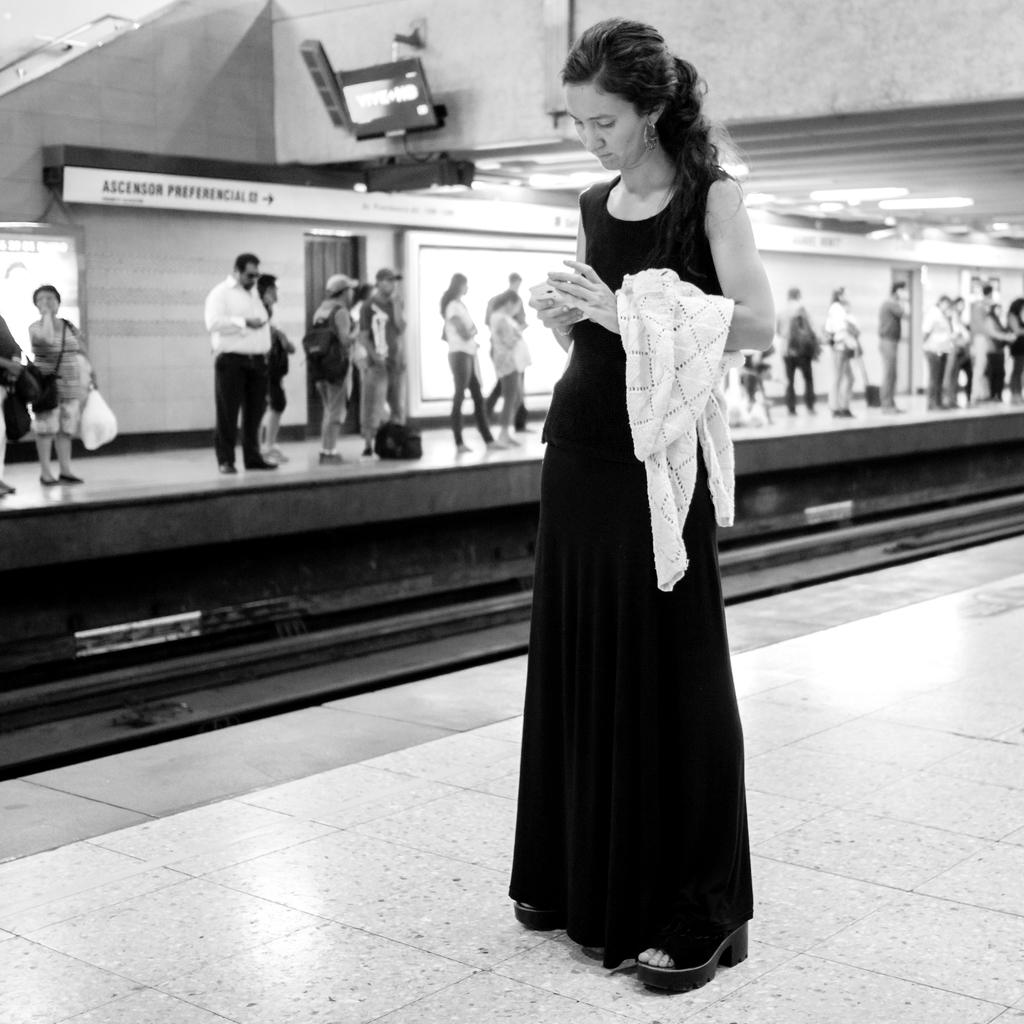What can be seen in the image involving transportation? There is a railway track and a platform in the image. What are the people in the image doing? The people are standing in the image. What is above the people in the image? The ceiling with lights is visible in the image. What is written or displayed on a surface in the image? There is text written on a wall in the image. What type of eggnog is being served to the people in the image? There is no eggnog present in the image. 